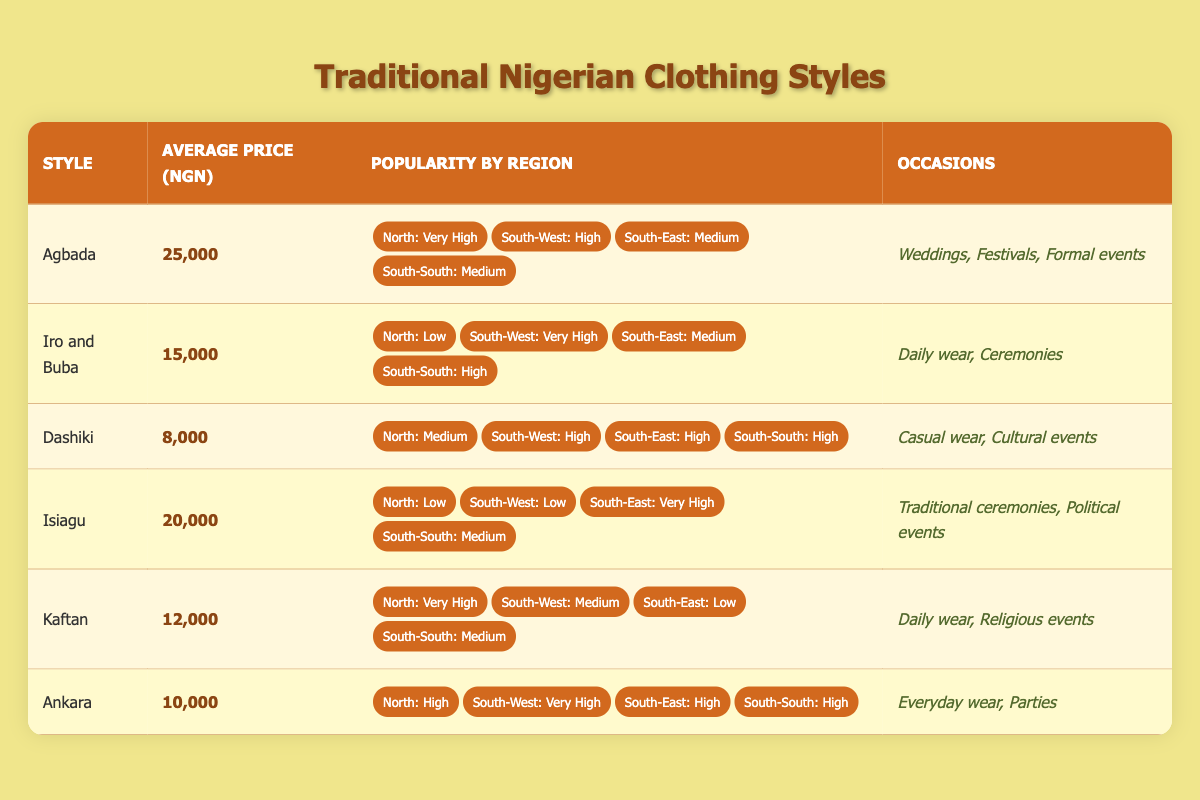What is the average price of Agbada? The average price listed in the table for Agbada is 25,000 NGN.
Answer: 25,000 NGN Which clothing style has very high popularity in the South-West and medium popularity in the South-East? By checking the popularity column, I see that Iro and Buba has 'Very High' popularity in the South-West and 'Medium' in the South-East.
Answer: Iro and Buba Is the Dashiki more popular in the North than in the South-East? The table shows Dashiki with 'Medium' popularity in the North and 'High' popularity in the South-East, so it is not more popular in the North than in the South-East.
Answer: No How much more expensive is Agbada compared to Kaftan? The average price of Agbada is 25,000 NGN and Kaftan is 12,000 NGN. To calculate the difference: 25,000 - 12,000 = 13,000 NGN.
Answer: 13,000 NGN Which styles are available for weddings and what is their average price? Agbada is available for weddings at 25,000 NGN, while Iro and Buba is also mentioned but not directly for weddings, with an average price of 15,000 NGN. Checking their availability on the occasions column shows Agbada is specifically for weddings. The average price for Agbada is 25,000 NGN.
Answer: 25,000 NGN (Agbada) What is the least expensive clothing style and its average price? By scanning the average prices, I see Dashiki has the lowest price listed at 8,000 NGN.
Answer: 8,000 NGN How many clothing styles are popular in the South-East? From the table, I will count how many styles have 'High' or 'Very High' popularity in the South-East: only Isiagu is ‘Very High’, while Agbada, Iro and Buba, Dashiki, and Ankara are ‘Medium’ or ‘High’, which sums it to four styles being popular.
Answer: 4 Is the Iro and Buba style popular in the North, and if so, what is its popularity level? According to the table, Iro and Buba has 'Low' popularity in the North. So, yes, it is popular but at a low level.
Answer: Yes, Low 